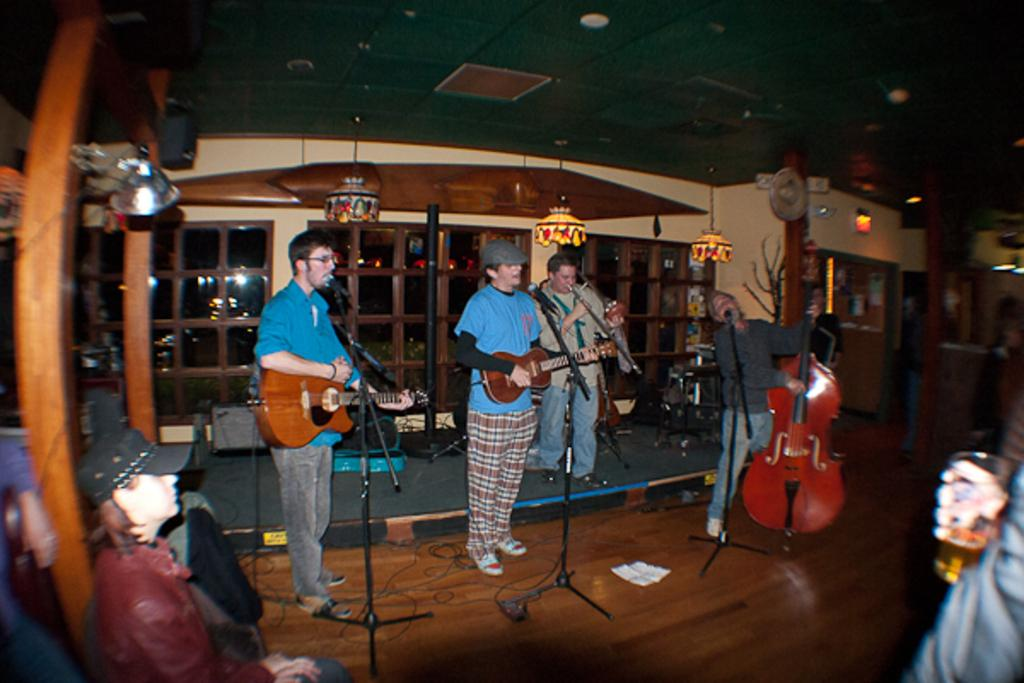How many people are present in the image? There are four people in the image. What are the people doing in the image? The people are playing musical instruments. Can you describe any additional objects or items in the image? There is a person holding a glass. What type of leaf is being used as a line to start the musical performance in the image? There is no leaf or line present in the image, and no indication of a musical performance being started. 